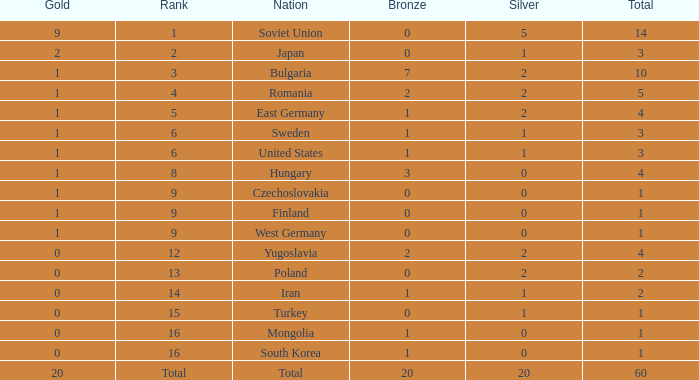What is the average silver for golds over 2, ranks of 1, and bronzes over 0? None. 